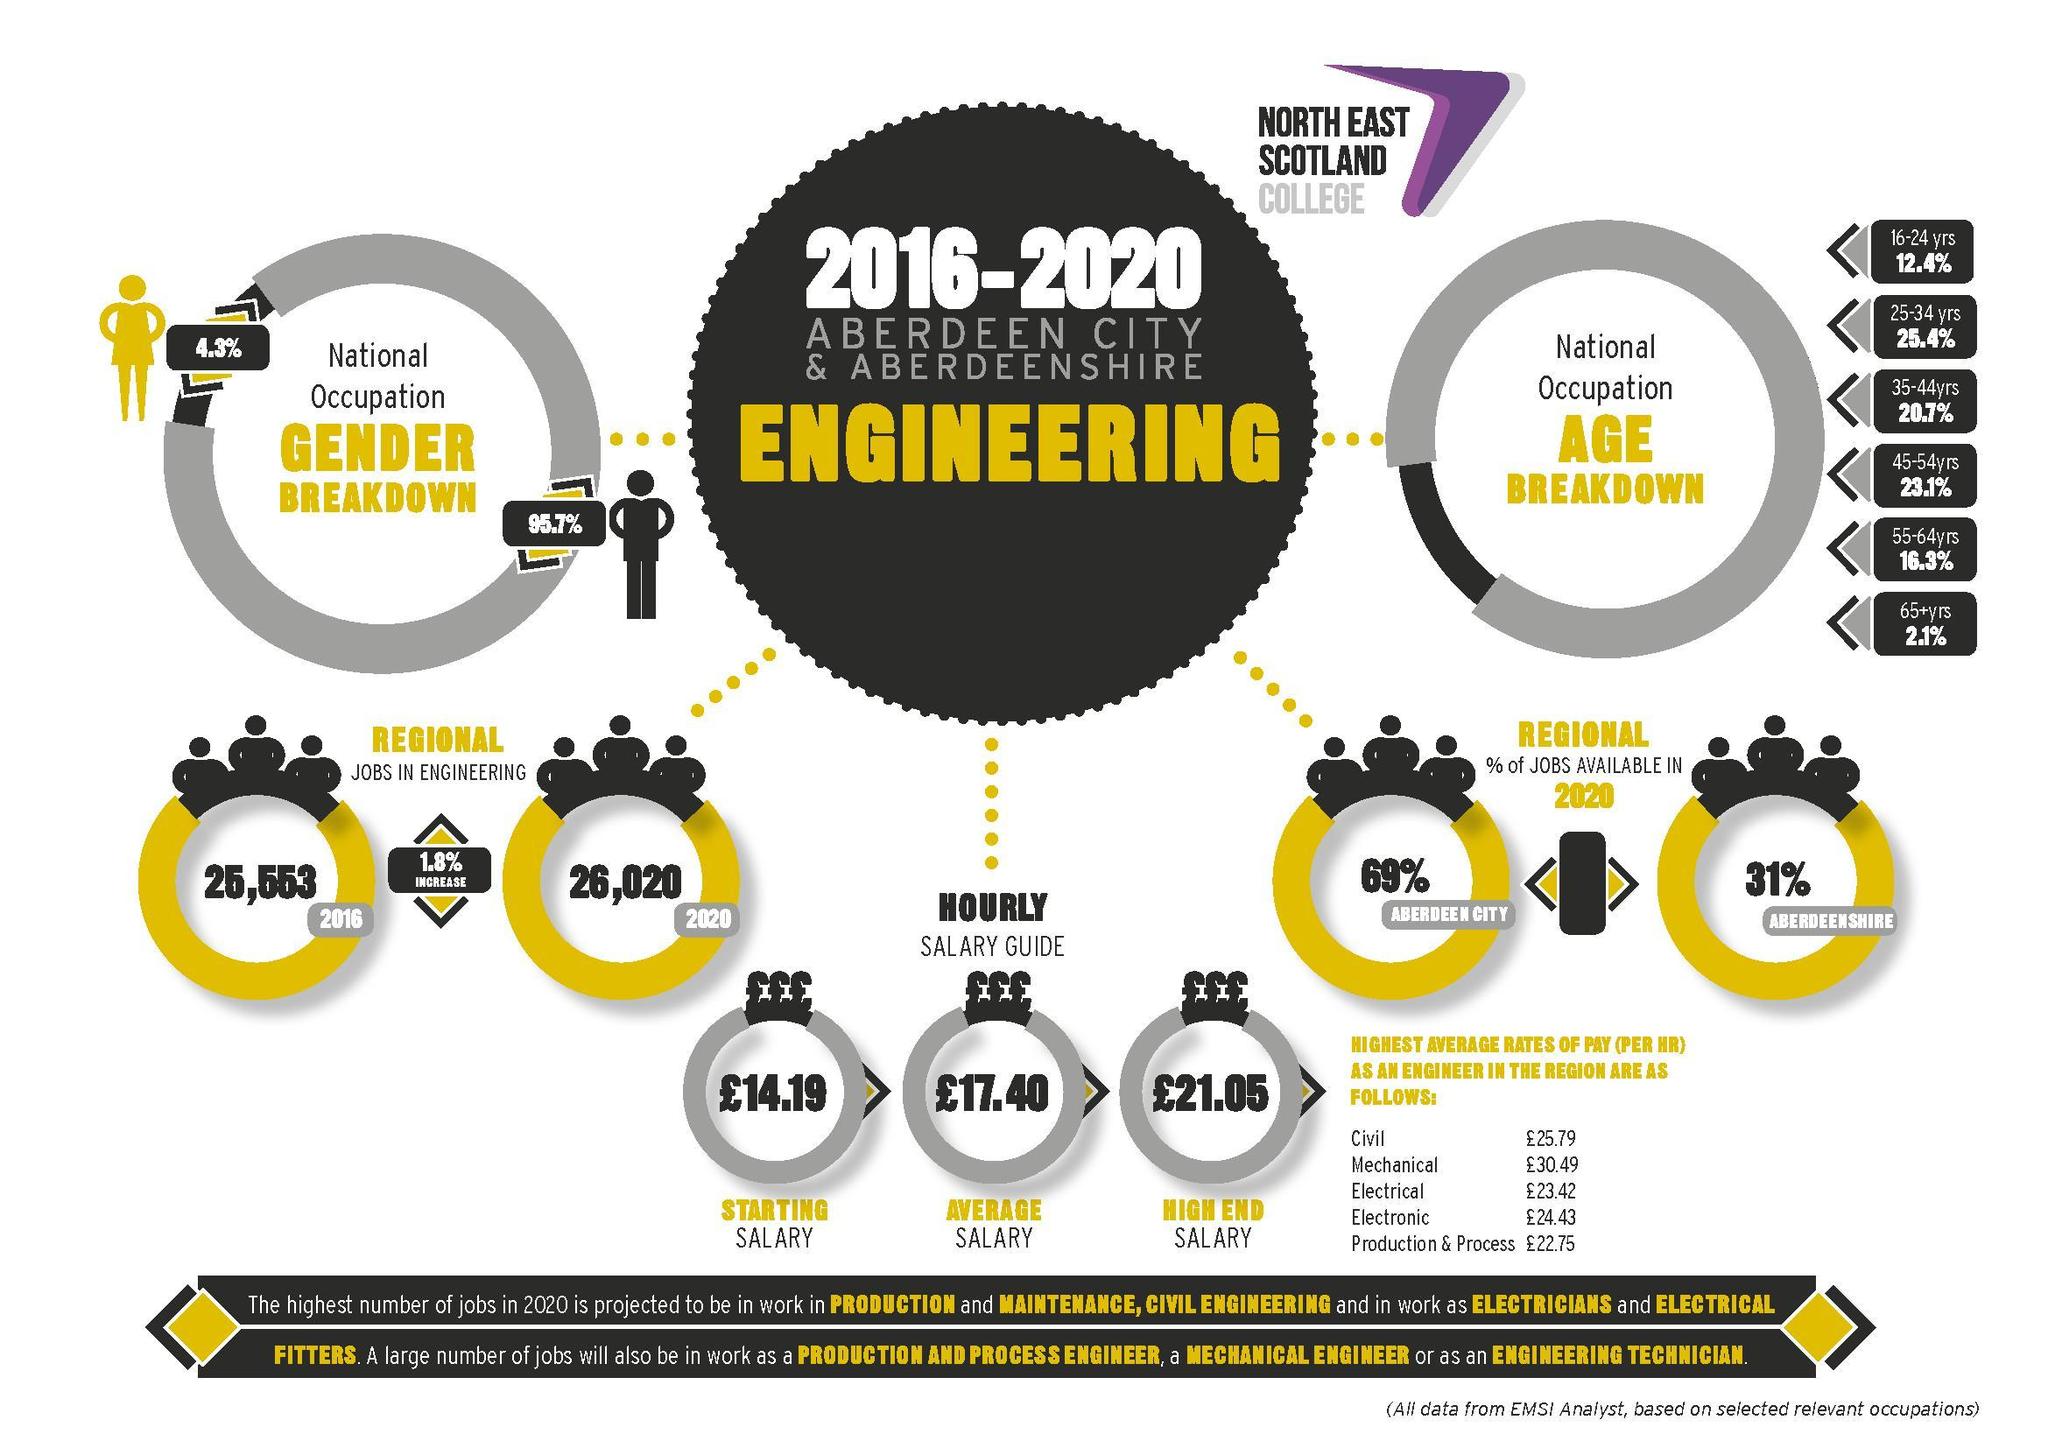How many sectors are given in the table showing the data of average rate of pay?
Answer the question with a short phrase. 5 What is the difference between starting hourly salary and high end hourly salary in pounds? 6.86 which age group has highest job share in engineering sector? 25-34 What is the difference between regional jobs in engineering in 2016 and jobs in 2020? 467 which age group has second highest job share in engineering sector? 45-54 yrs regional jobs in engineering in which year is higher - 2016 or 2020? 2020 Percentage of jobs available in which region is higher - Aberdeen shire or Aberdeen city? Aberdeen city average rates of pay is higher in which sector - civil or mechanical? mechanical What is the difference between average hourly salary and high end hourly salary in pounds? 3.65 What is the difference between average hourly salary and starting hourly salary in pounds? 3.21 which sector has the highest average rates of pay among the given sectors? mechanical What is the difference between average rates of pay of mechanical and electronics in pounds? 6.06 which sector has the lowest average rates of pay among the given sectors? production and process 